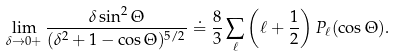Convert formula to latex. <formula><loc_0><loc_0><loc_500><loc_500>\lim _ { \delta \rightarrow 0 + } \frac { \delta \sin ^ { 2 } \Theta } { ( \delta ^ { 2 } + 1 - \cos \Theta ) ^ { 5 / 2 } } \doteq \frac { 8 } { 3 } \sum _ { \ell } \left ( \ell + \frac { 1 } { 2 } \right ) P _ { \ell } ( \cos \Theta ) .</formula> 